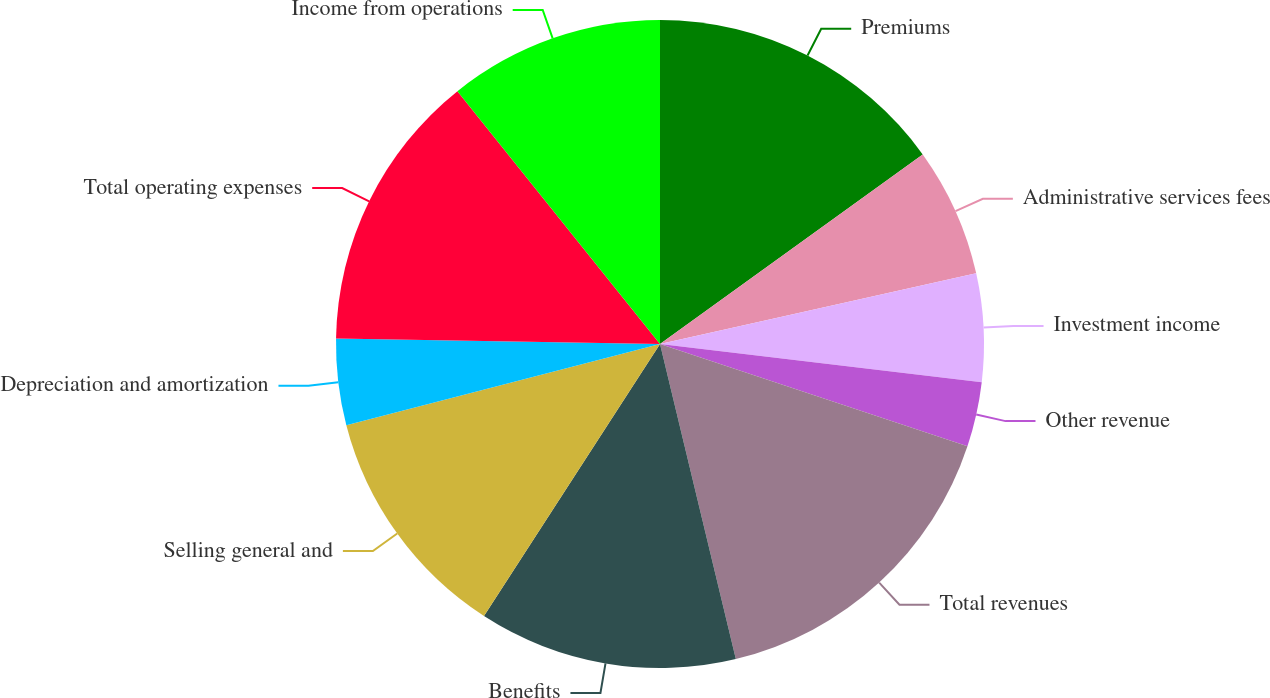Convert chart. <chart><loc_0><loc_0><loc_500><loc_500><pie_chart><fcel>Premiums<fcel>Administrative services fees<fcel>Investment income<fcel>Other revenue<fcel>Total revenues<fcel>Benefits<fcel>Selling general and<fcel>Depreciation and amortization<fcel>Total operating expenses<fcel>Income from operations<nl><fcel>15.05%<fcel>6.45%<fcel>5.38%<fcel>3.23%<fcel>16.13%<fcel>12.9%<fcel>11.83%<fcel>4.3%<fcel>13.98%<fcel>10.75%<nl></chart> 